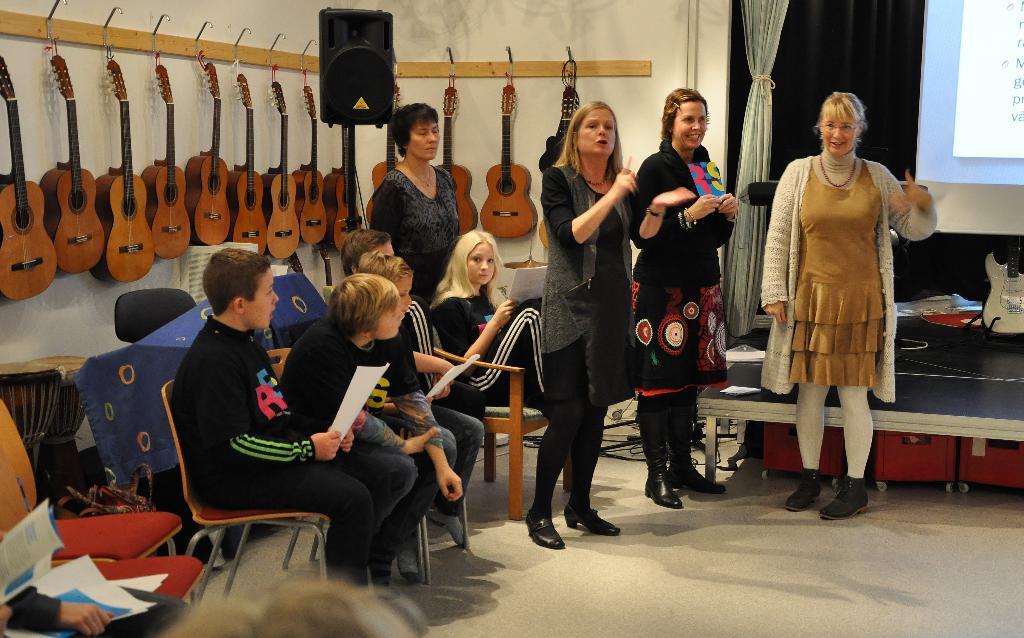Please provide a concise description of this image. In this image we can see people sitting on chairs. There are people standing. In the background of the image there are guitars hanged on the wall. 